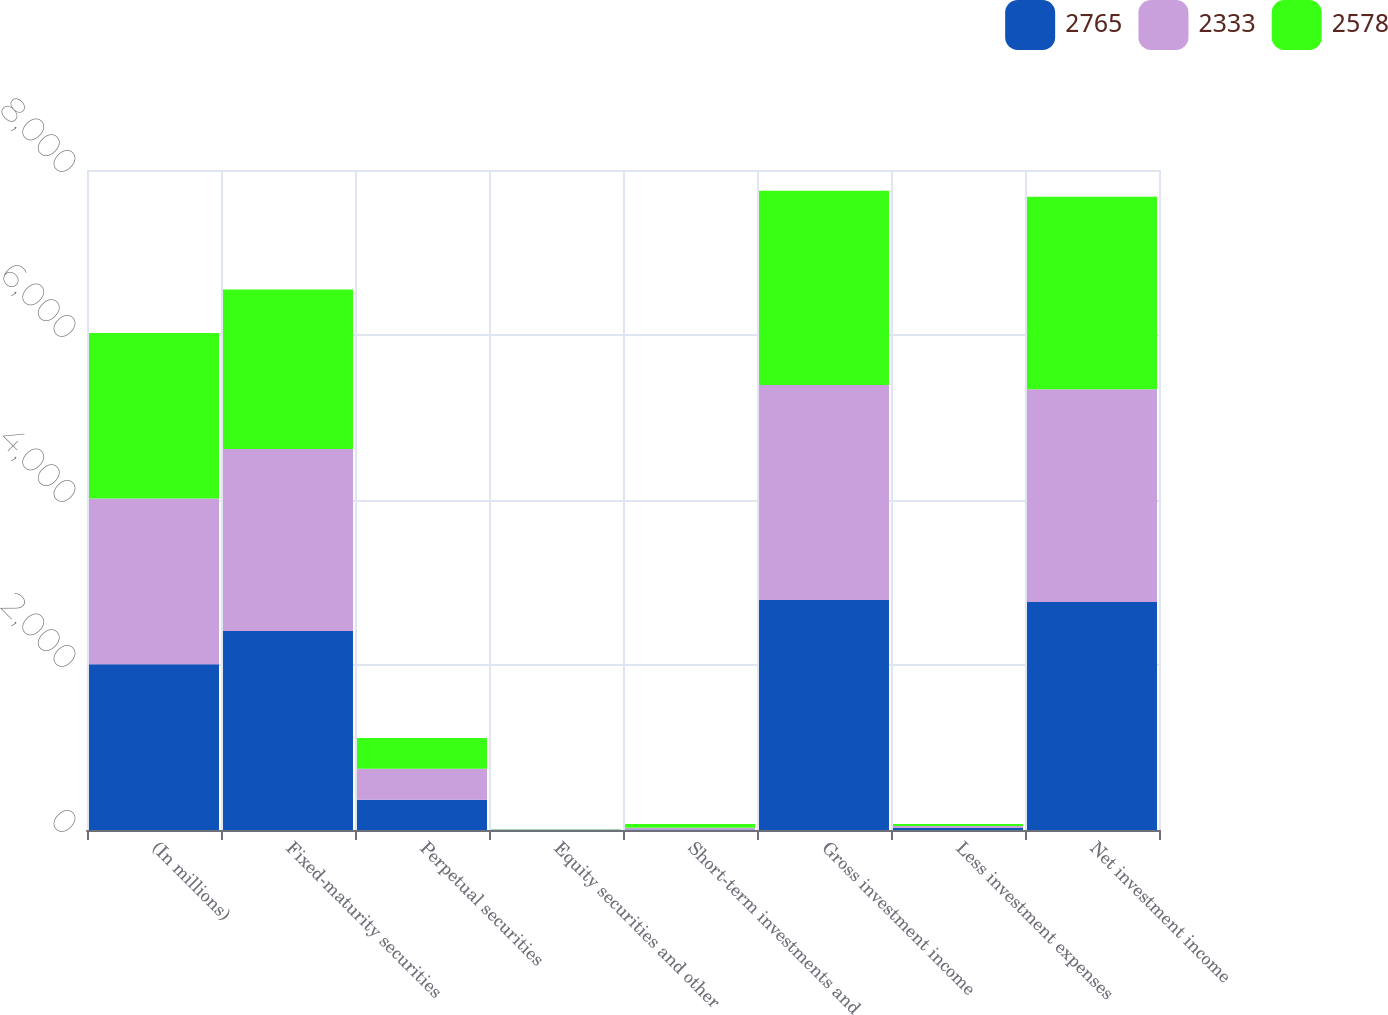Convert chart. <chart><loc_0><loc_0><loc_500><loc_500><stacked_bar_chart><ecel><fcel>(In millions)<fcel>Fixed-maturity securities<fcel>Perpetual securities<fcel>Equity securities and other<fcel>Short-term investments and<fcel>Gross investment income<fcel>Less investment expenses<fcel>Net investment income<nl><fcel>2765<fcel>2009<fcel>2413<fcel>367<fcel>3<fcel>6<fcel>2789<fcel>24<fcel>2765<nl><fcel>2333<fcel>2008<fcel>2204<fcel>375<fcel>3<fcel>22<fcel>2604<fcel>26<fcel>2578<nl><fcel>2578<fcel>2007<fcel>1936<fcel>372<fcel>2<fcel>45<fcel>2355<fcel>22<fcel>2333<nl></chart> 